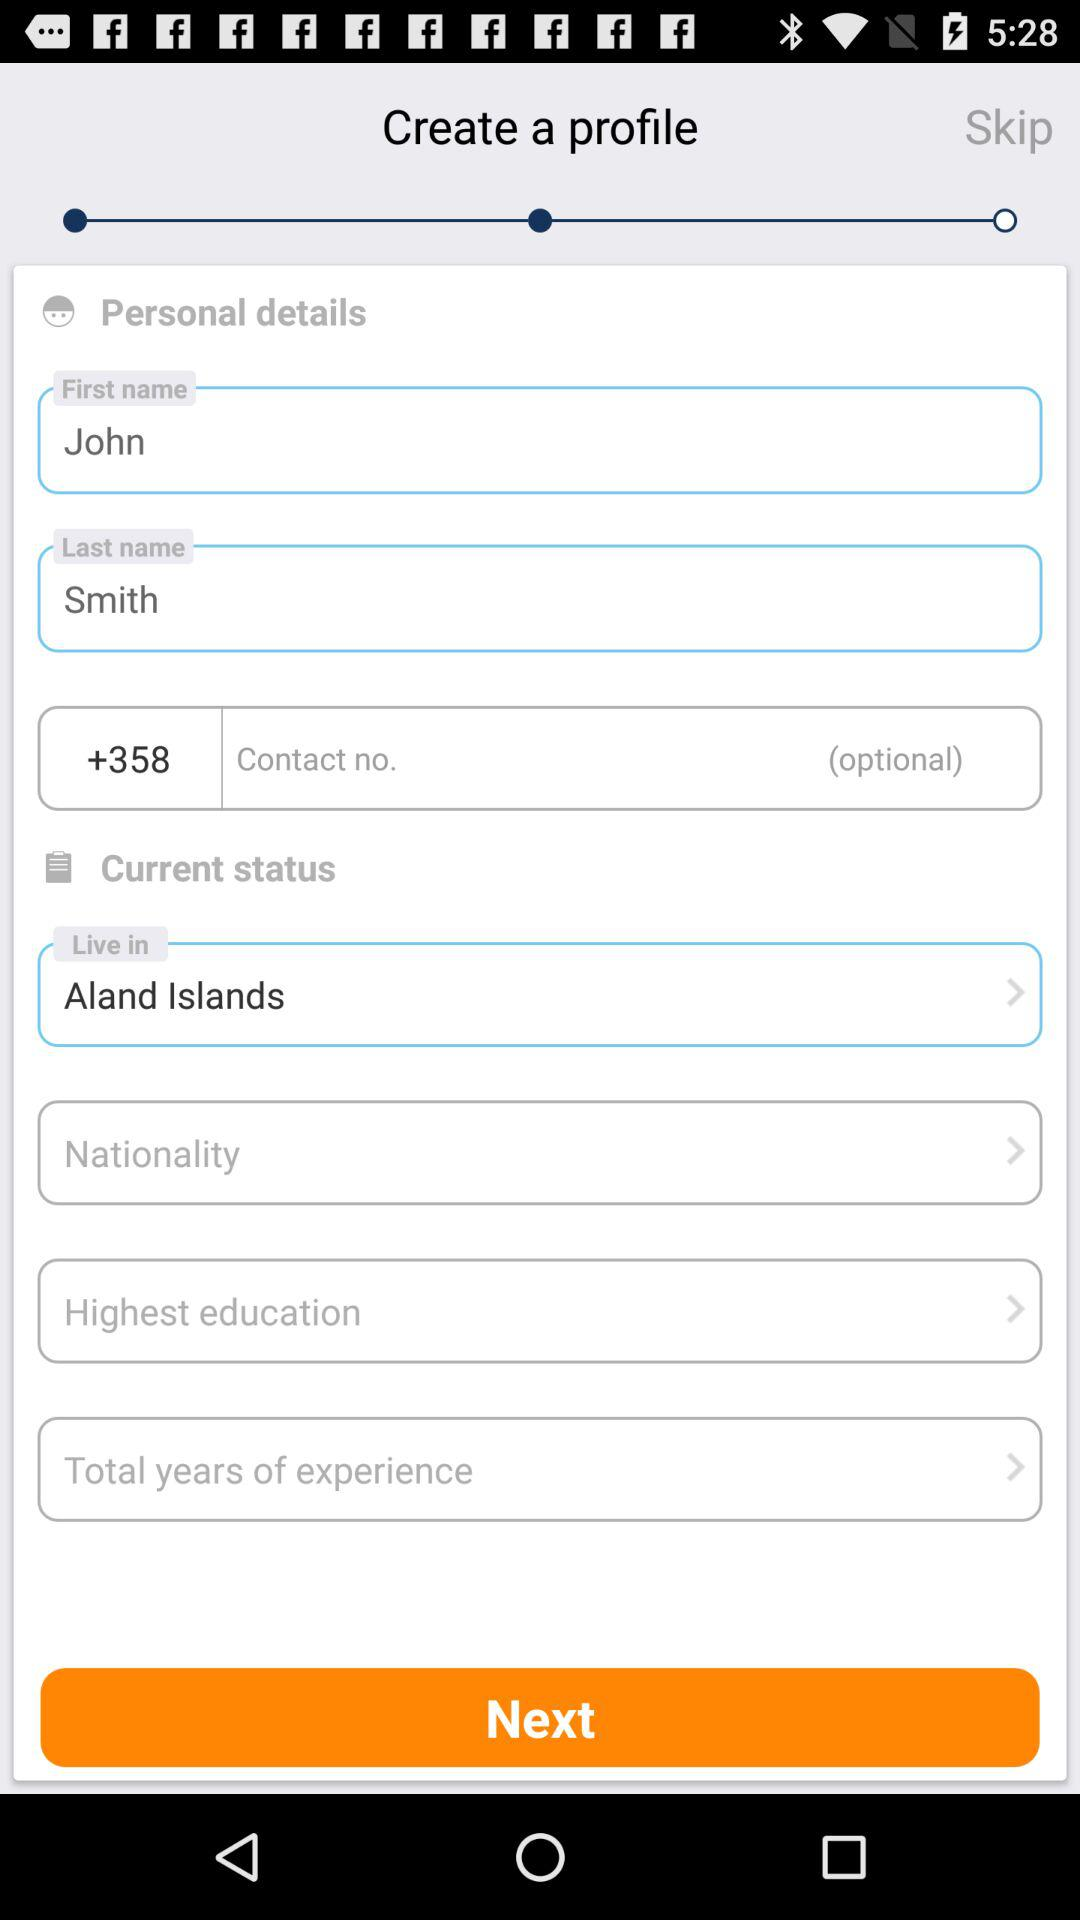What is first name? The first name is John. 